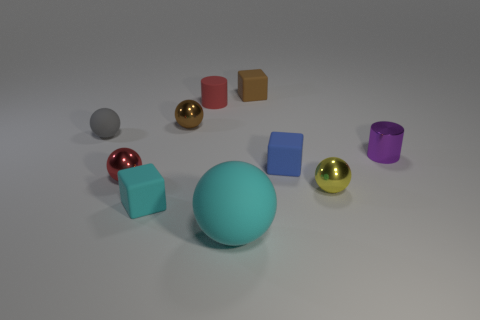Can you tell me which objects in the image are reflective? Certainly! In the image, the objects that exhibit reflectivity are the two round orbs with a shiny surface, one in metallic red and another in glossy gold. Their surfaces reflect the environment, showing the characteristics of specular reflection. 